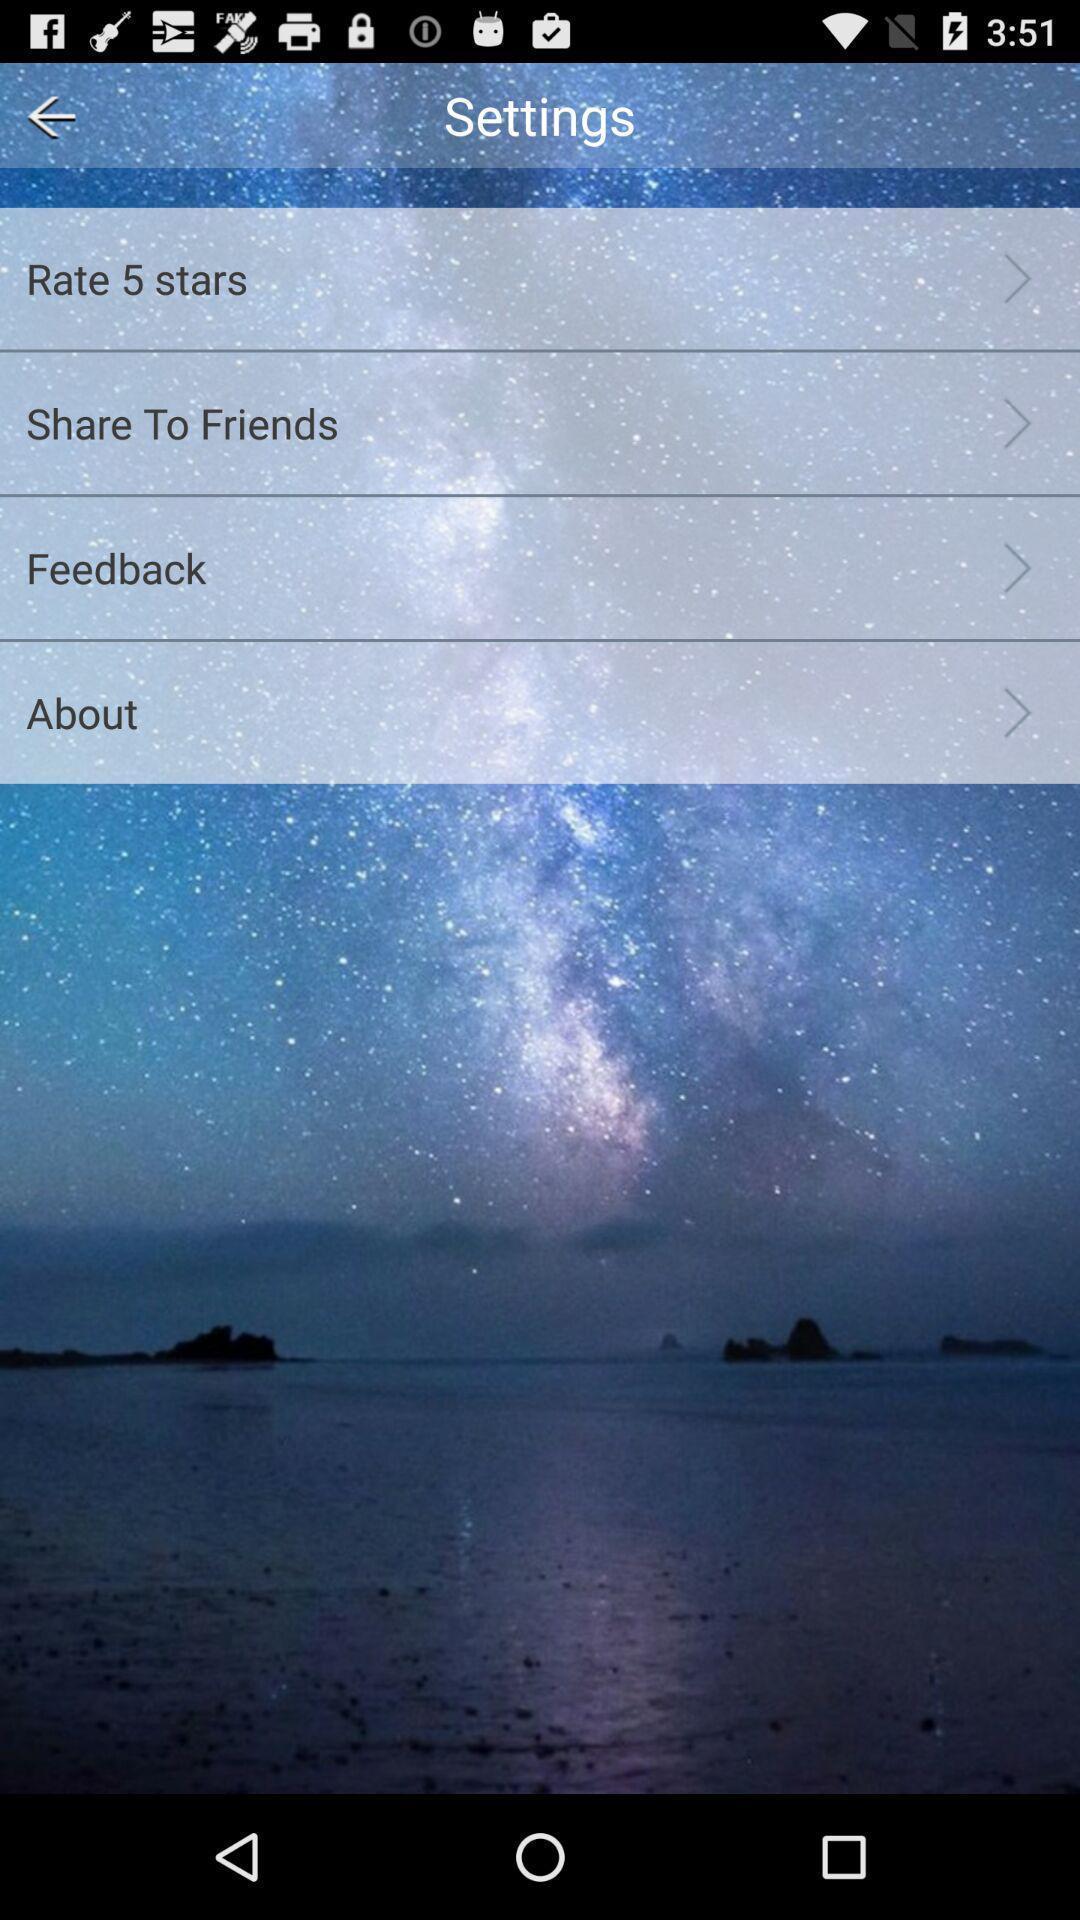Provide a detailed account of this screenshot. Page showing settings section. 